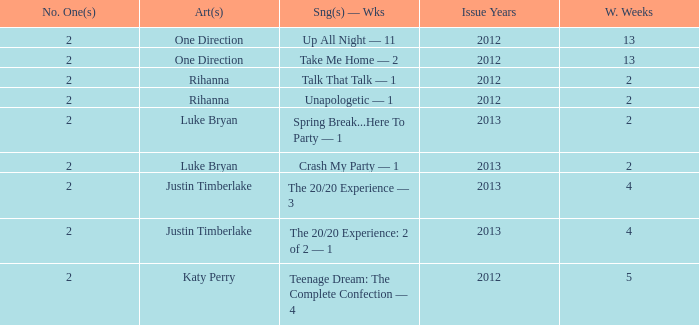What is the title of every song, and how many weeks was each song at #1 for Rihanna in 2012? Talk That Talk — 1, Unapologetic — 1. 